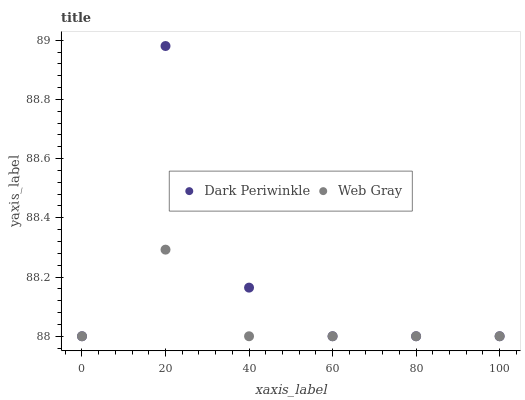Does Web Gray have the minimum area under the curve?
Answer yes or no. Yes. Does Dark Periwinkle have the maximum area under the curve?
Answer yes or no. Yes. Does Dark Periwinkle have the minimum area under the curve?
Answer yes or no. No. Is Web Gray the smoothest?
Answer yes or no. Yes. Is Dark Periwinkle the roughest?
Answer yes or no. Yes. Is Dark Periwinkle the smoothest?
Answer yes or no. No. Does Web Gray have the lowest value?
Answer yes or no. Yes. Does Dark Periwinkle have the highest value?
Answer yes or no. Yes. Does Web Gray intersect Dark Periwinkle?
Answer yes or no. Yes. Is Web Gray less than Dark Periwinkle?
Answer yes or no. No. Is Web Gray greater than Dark Periwinkle?
Answer yes or no. No. 